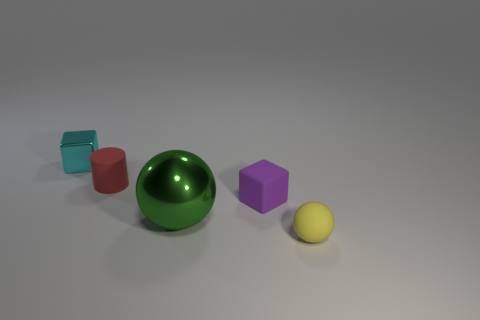Add 3 tiny purple things. How many objects exist? 8 Subtract all cubes. How many objects are left? 3 Add 5 small green cylinders. How many small green cylinders exist? 5 Subtract 0 red cubes. How many objects are left? 5 Subtract all blue cubes. Subtract all small matte balls. How many objects are left? 4 Add 2 yellow things. How many yellow things are left? 3 